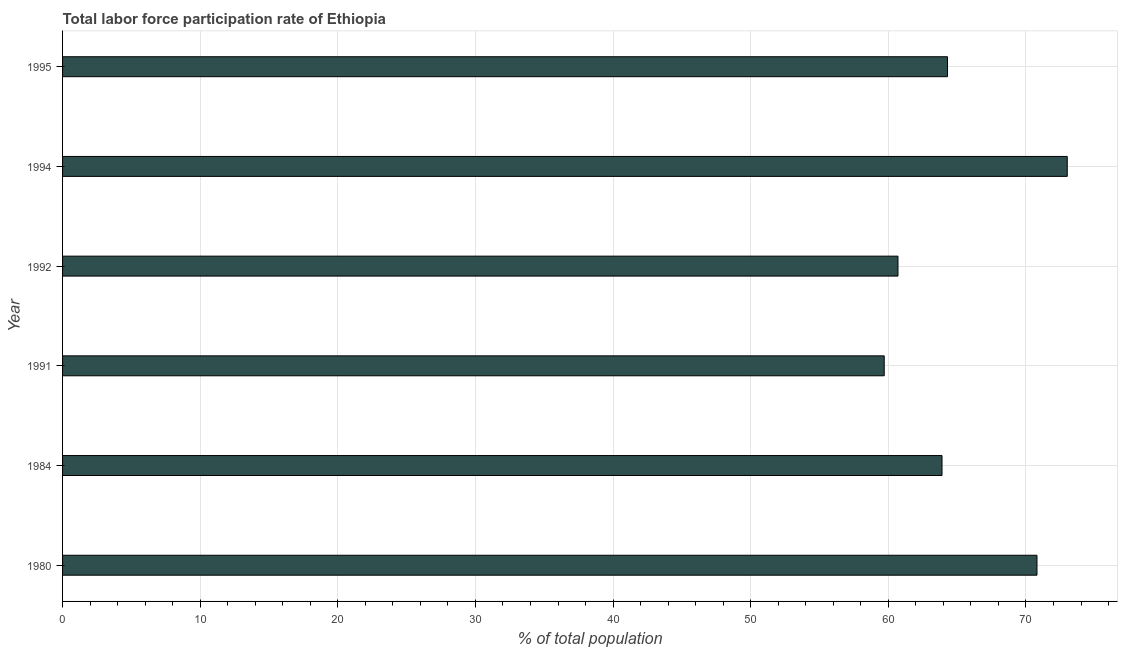Does the graph contain any zero values?
Your response must be concise. No. What is the title of the graph?
Ensure brevity in your answer.  Total labor force participation rate of Ethiopia. What is the label or title of the X-axis?
Your response must be concise. % of total population. What is the total labor force participation rate in 1995?
Your answer should be compact. 64.3. Across all years, what is the maximum total labor force participation rate?
Make the answer very short. 73. Across all years, what is the minimum total labor force participation rate?
Give a very brief answer. 59.7. In which year was the total labor force participation rate maximum?
Ensure brevity in your answer.  1994. What is the sum of the total labor force participation rate?
Keep it short and to the point. 392.4. What is the difference between the total labor force participation rate in 1991 and 1995?
Make the answer very short. -4.6. What is the average total labor force participation rate per year?
Provide a succinct answer. 65.4. What is the median total labor force participation rate?
Offer a very short reply. 64.1. Do a majority of the years between 1992 and 1980 (inclusive) have total labor force participation rate greater than 34 %?
Make the answer very short. Yes. What is the ratio of the total labor force participation rate in 1980 to that in 1992?
Your answer should be very brief. 1.17. Is the total labor force participation rate in 1992 less than that in 1994?
Offer a terse response. Yes. What is the difference between the highest and the second highest total labor force participation rate?
Provide a succinct answer. 2.2. Is the sum of the total labor force participation rate in 1984 and 1995 greater than the maximum total labor force participation rate across all years?
Make the answer very short. Yes. What is the difference between the highest and the lowest total labor force participation rate?
Your answer should be very brief. 13.3. How many years are there in the graph?
Offer a very short reply. 6. What is the difference between two consecutive major ticks on the X-axis?
Offer a very short reply. 10. Are the values on the major ticks of X-axis written in scientific E-notation?
Keep it short and to the point. No. What is the % of total population in 1980?
Offer a terse response. 70.8. What is the % of total population in 1984?
Make the answer very short. 63.9. What is the % of total population of 1991?
Provide a short and direct response. 59.7. What is the % of total population in 1992?
Give a very brief answer. 60.7. What is the % of total population in 1994?
Offer a terse response. 73. What is the % of total population of 1995?
Your answer should be compact. 64.3. What is the difference between the % of total population in 1980 and 1991?
Ensure brevity in your answer.  11.1. What is the difference between the % of total population in 1980 and 1994?
Keep it short and to the point. -2.2. What is the difference between the % of total population in 1991 and 1992?
Your answer should be very brief. -1. What is the difference between the % of total population in 1991 and 1995?
Provide a succinct answer. -4.6. What is the difference between the % of total population in 1992 and 1994?
Make the answer very short. -12.3. What is the ratio of the % of total population in 1980 to that in 1984?
Offer a very short reply. 1.11. What is the ratio of the % of total population in 1980 to that in 1991?
Provide a succinct answer. 1.19. What is the ratio of the % of total population in 1980 to that in 1992?
Offer a very short reply. 1.17. What is the ratio of the % of total population in 1980 to that in 1994?
Your response must be concise. 0.97. What is the ratio of the % of total population in 1980 to that in 1995?
Ensure brevity in your answer.  1.1. What is the ratio of the % of total population in 1984 to that in 1991?
Your answer should be compact. 1.07. What is the ratio of the % of total population in 1984 to that in 1992?
Offer a terse response. 1.05. What is the ratio of the % of total population in 1984 to that in 1994?
Provide a short and direct response. 0.88. What is the ratio of the % of total population in 1984 to that in 1995?
Ensure brevity in your answer.  0.99. What is the ratio of the % of total population in 1991 to that in 1994?
Offer a terse response. 0.82. What is the ratio of the % of total population in 1991 to that in 1995?
Provide a succinct answer. 0.93. What is the ratio of the % of total population in 1992 to that in 1994?
Make the answer very short. 0.83. What is the ratio of the % of total population in 1992 to that in 1995?
Provide a short and direct response. 0.94. What is the ratio of the % of total population in 1994 to that in 1995?
Provide a succinct answer. 1.14. 